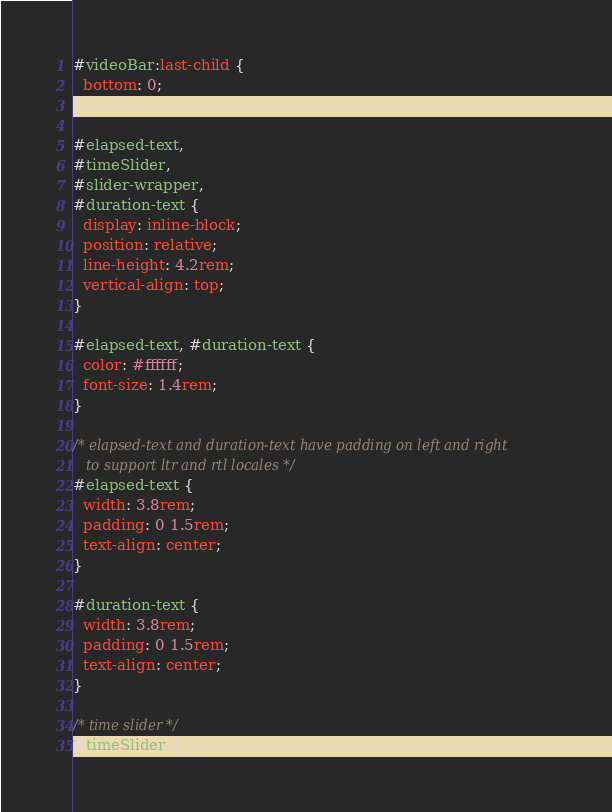<code> <loc_0><loc_0><loc_500><loc_500><_CSS_>#videoBar:last-child {
  bottom: 0;
}

#elapsed-text,
#timeSlider,
#slider-wrapper,
#duration-text {
  display: inline-block;
  position: relative;
  line-height: 4.2rem;
  vertical-align: top;
}

#elapsed-text, #duration-text {
  color: #ffffff;
  font-size: 1.4rem;
}

/* elapsed-text and duration-text have padding on left and right
   to support ltr and rtl locales */
#elapsed-text {
  width: 3.8rem;
  padding: 0 1.5rem;
  text-align: center;
}

#duration-text {
  width: 3.8rem;
  padding: 0 1.5rem;
  text-align: center;
}

/* time slider */
#timeSlider {</code> 